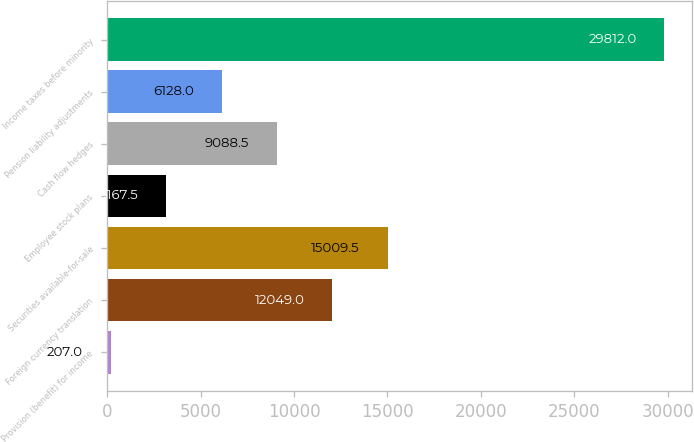Convert chart to OTSL. <chart><loc_0><loc_0><loc_500><loc_500><bar_chart><fcel>Provision (benefit) for income<fcel>Foreign currency translation<fcel>Securities available-for-sale<fcel>Employee stock plans<fcel>Cash flow hedges<fcel>Pension liability adjustments<fcel>Income taxes before minority<nl><fcel>207<fcel>12049<fcel>15009.5<fcel>3167.5<fcel>9088.5<fcel>6128<fcel>29812<nl></chart> 